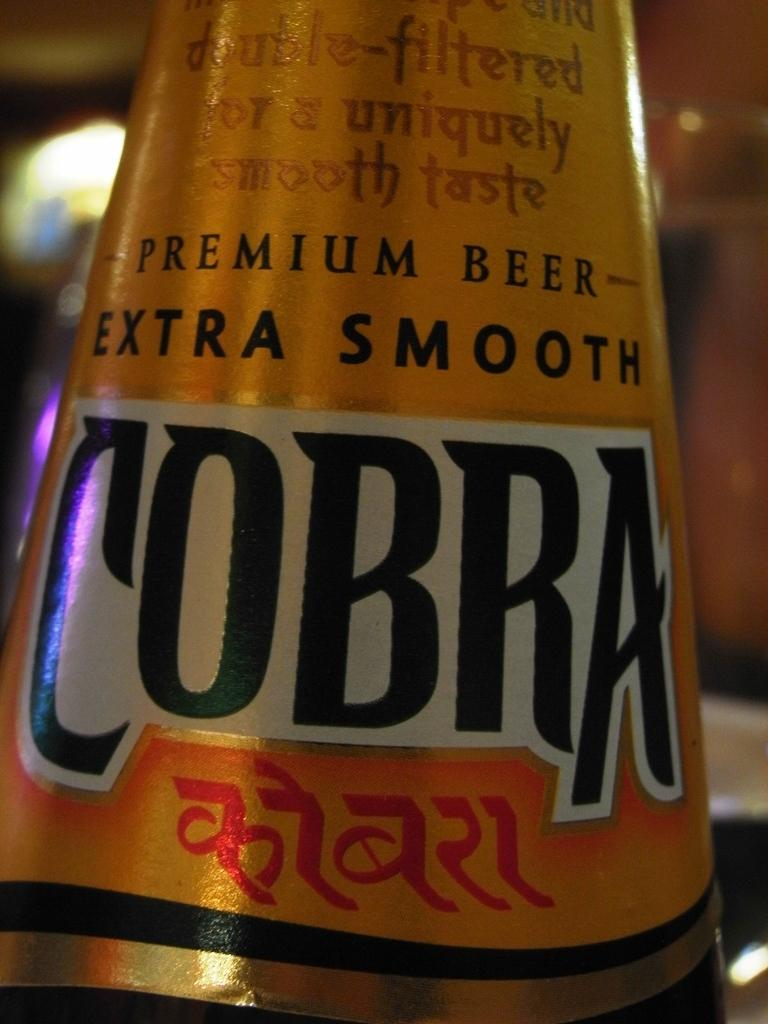Provide a one-sentence caption for the provided image. a closeup of the label for Cobra premium beer extra smooth. 